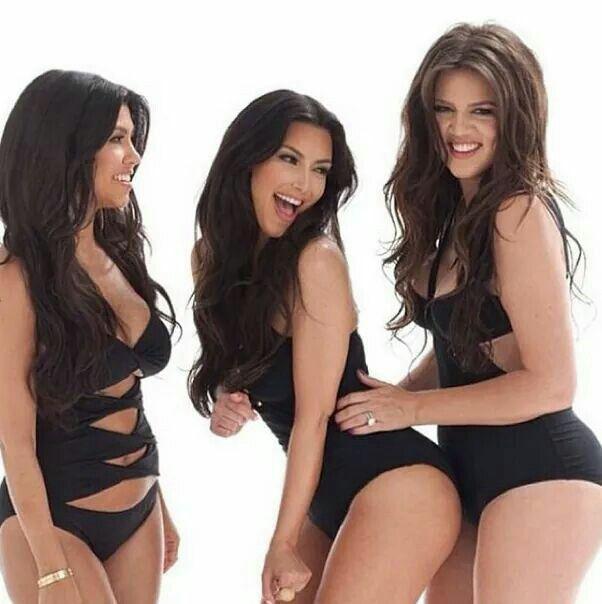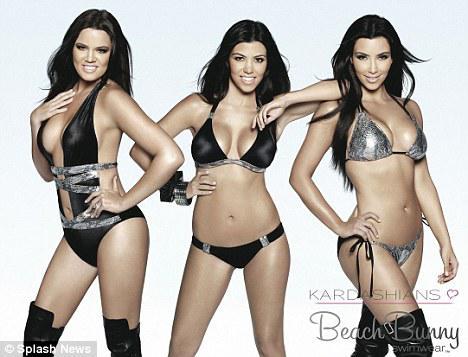The first image is the image on the left, the second image is the image on the right. For the images shown, is this caption "A model's bare foot appears in at least one of the images." true? Answer yes or no. No. 